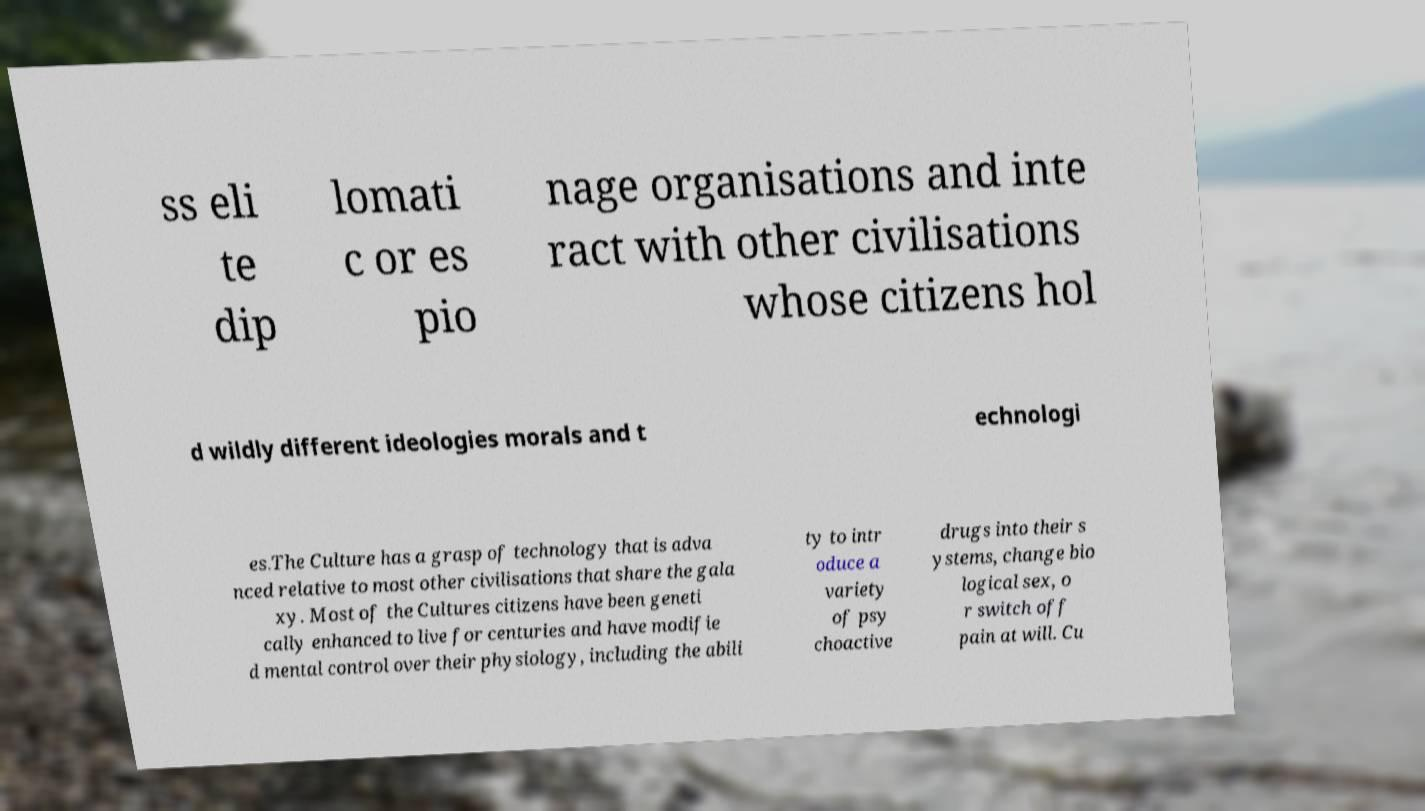There's text embedded in this image that I need extracted. Can you transcribe it verbatim? ss eli te dip lomati c or es pio nage organisations and inte ract with other civilisations whose citizens hol d wildly different ideologies morals and t echnologi es.The Culture has a grasp of technology that is adva nced relative to most other civilisations that share the gala xy. Most of the Cultures citizens have been geneti cally enhanced to live for centuries and have modifie d mental control over their physiology, including the abili ty to intr oduce a variety of psy choactive drugs into their s ystems, change bio logical sex, o r switch off pain at will. Cu 